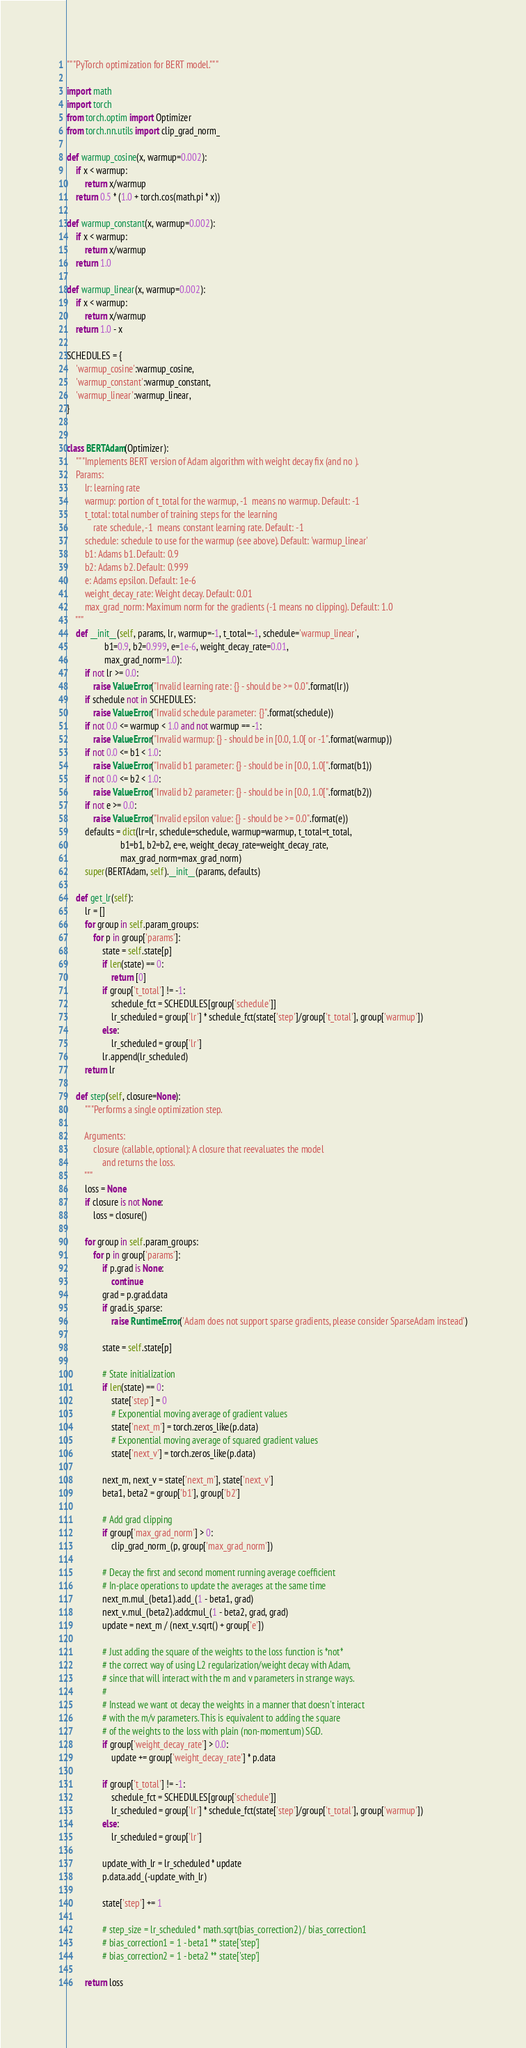<code> <loc_0><loc_0><loc_500><loc_500><_Python_>
"""PyTorch optimization for BERT model."""

import math
import torch
from torch.optim import Optimizer
from torch.nn.utils import clip_grad_norm_

def warmup_cosine(x, warmup=0.002):
    if x < warmup:
        return x/warmup
    return 0.5 * (1.0 + torch.cos(math.pi * x))

def warmup_constant(x, warmup=0.002):
    if x < warmup:
        return x/warmup
    return 1.0

def warmup_linear(x, warmup=0.002):
    if x < warmup:
        return x/warmup
    return 1.0 - x

SCHEDULES = {
    'warmup_cosine':warmup_cosine,
    'warmup_constant':warmup_constant,
    'warmup_linear':warmup_linear,
}


class BERTAdam(Optimizer):
    """Implements BERT version of Adam algorithm with weight decay fix (and no ).
    Params:
        lr: learning rate
        warmup: portion of t_total for the warmup, -1  means no warmup. Default: -1
        t_total: total number of training steps for the learning
            rate schedule, -1  means constant learning rate. Default: -1
        schedule: schedule to use for the warmup (see above). Default: 'warmup_linear'
        b1: Adams b1. Default: 0.9
        b2: Adams b2. Default: 0.999
        e: Adams epsilon. Default: 1e-6
        weight_decay_rate: Weight decay. Default: 0.01
        max_grad_norm: Maximum norm for the gradients (-1 means no clipping). Default: 1.0
    """
    def __init__(self, params, lr, warmup=-1, t_total=-1, schedule='warmup_linear',
                 b1=0.9, b2=0.999, e=1e-6, weight_decay_rate=0.01,
                 max_grad_norm=1.0):
        if not lr >= 0.0:
            raise ValueError("Invalid learning rate: {} - should be >= 0.0".format(lr))
        if schedule not in SCHEDULES:
            raise ValueError("Invalid schedule parameter: {}".format(schedule))
        if not 0.0 <= warmup < 1.0 and not warmup == -1:
            raise ValueError("Invalid warmup: {} - should be in [0.0, 1.0[ or -1".format(warmup))
        if not 0.0 <= b1 < 1.0:
            raise ValueError("Invalid b1 parameter: {} - should be in [0.0, 1.0[".format(b1))
        if not 0.0 <= b2 < 1.0:
            raise ValueError("Invalid b2 parameter: {} - should be in [0.0, 1.0[".format(b2))
        if not e >= 0.0:
            raise ValueError("Invalid epsilon value: {} - should be >= 0.0".format(e))
        defaults = dict(lr=lr, schedule=schedule, warmup=warmup, t_total=t_total,
                        b1=b1, b2=b2, e=e, weight_decay_rate=weight_decay_rate,
                        max_grad_norm=max_grad_norm)
        super(BERTAdam, self).__init__(params, defaults)

    def get_lr(self):
        lr = []
        for group in self.param_groups:
            for p in group['params']:
                state = self.state[p]
                if len(state) == 0:
                    return [0]
                if group['t_total'] != -1:
                    schedule_fct = SCHEDULES[group['schedule']]
                    lr_scheduled = group['lr'] * schedule_fct(state['step']/group['t_total'], group['warmup'])
                else:
                    lr_scheduled = group['lr']
                lr.append(lr_scheduled)
        return lr

    def step(self, closure=None):
        """Performs a single optimization step.

        Arguments:
            closure (callable, optional): A closure that reevaluates the model
                and returns the loss.
        """
        loss = None
        if closure is not None:
            loss = closure()

        for group in self.param_groups:
            for p in group['params']:
                if p.grad is None:
                    continue
                grad = p.grad.data
                if grad.is_sparse:
                    raise RuntimeError('Adam does not support sparse gradients, please consider SparseAdam instead')

                state = self.state[p]

                # State initialization
                if len(state) == 0:
                    state['step'] = 0
                    # Exponential moving average of gradient values
                    state['next_m'] = torch.zeros_like(p.data)
                    # Exponential moving average of squared gradient values
                    state['next_v'] = torch.zeros_like(p.data)

                next_m, next_v = state['next_m'], state['next_v']
                beta1, beta2 = group['b1'], group['b2']

                # Add grad clipping
                if group['max_grad_norm'] > 0:
                    clip_grad_norm_(p, group['max_grad_norm'])

                # Decay the first and second moment running average coefficient
                # In-place operations to update the averages at the same time
                next_m.mul_(beta1).add_(1 - beta1, grad)
                next_v.mul_(beta2).addcmul_(1 - beta2, grad, grad)
                update = next_m / (next_v.sqrt() + group['e'])

                # Just adding the square of the weights to the loss function is *not*
                # the correct way of using L2 regularization/weight decay with Adam,
                # since that will interact with the m and v parameters in strange ways.
                #
                # Instead we want ot decay the weights in a manner that doesn't interact
                # with the m/v parameters. This is equivalent to adding the square
                # of the weights to the loss with plain (non-momentum) SGD.
                if group['weight_decay_rate'] > 0.0:
                    update += group['weight_decay_rate'] * p.data

                if group['t_total'] != -1:
                    schedule_fct = SCHEDULES[group['schedule']]
                    lr_scheduled = group['lr'] * schedule_fct(state['step']/group['t_total'], group['warmup'])
                else:
                    lr_scheduled = group['lr']

                update_with_lr = lr_scheduled * update
                p.data.add_(-update_with_lr)

                state['step'] += 1

                # step_size = lr_scheduled * math.sqrt(bias_correction2) / bias_correction1
                # bias_correction1 = 1 - beta1 ** state['step']
                # bias_correction2 = 1 - beta2 ** state['step']

        return loss
</code> 